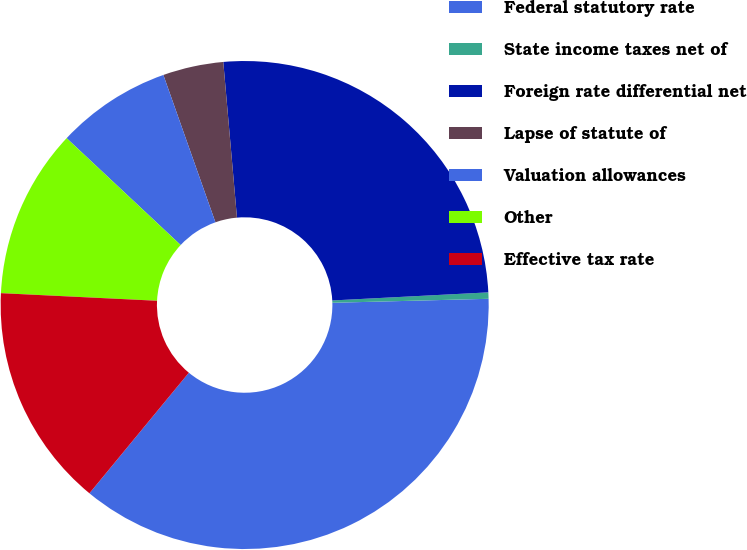<chart> <loc_0><loc_0><loc_500><loc_500><pie_chart><fcel>Federal statutory rate<fcel>State income taxes net of<fcel>Foreign rate differential net<fcel>Lapse of statute of<fcel>Valuation allowances<fcel>Other<fcel>Effective tax rate<nl><fcel>36.38%<fcel>0.42%<fcel>25.57%<fcel>4.01%<fcel>7.61%<fcel>11.21%<fcel>14.8%<nl></chart> 